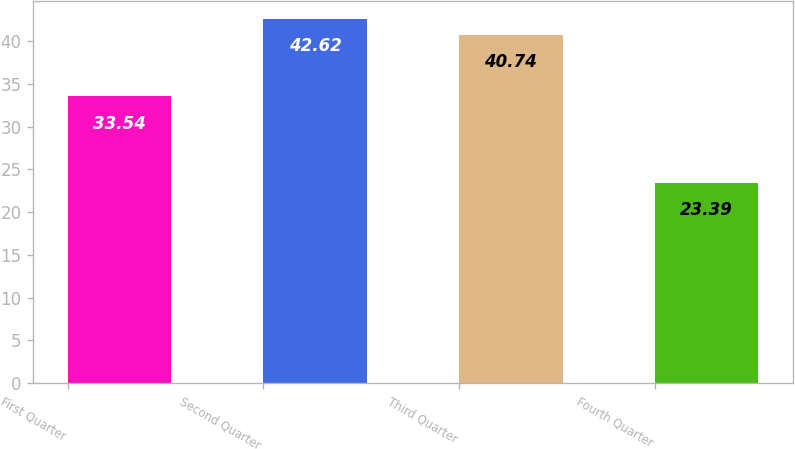<chart> <loc_0><loc_0><loc_500><loc_500><bar_chart><fcel>First Quarter<fcel>Second Quarter<fcel>Third Quarter<fcel>Fourth Quarter<nl><fcel>33.54<fcel>42.62<fcel>40.74<fcel>23.39<nl></chart> 